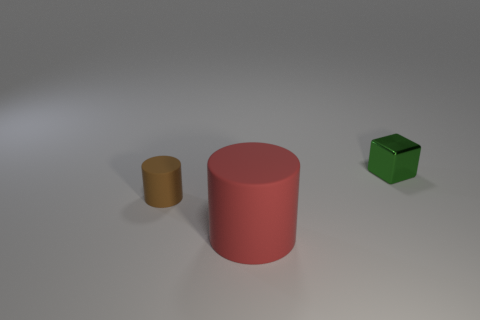How big is the thing on the right side of the big matte thing?
Provide a short and direct response. Small. Does the brown cylinder have the same material as the big cylinder?
Your answer should be compact. Yes. There is a red object that is the same material as the brown cylinder; what is its shape?
Your answer should be very brief. Cylinder. Is there anything else that has the same color as the metallic block?
Keep it short and to the point. No. What is the color of the small object that is to the left of the tiny block?
Your answer should be very brief. Brown. There is a object on the right side of the big red cylinder; is it the same color as the small matte object?
Your answer should be compact. No. There is another thing that is the same shape as the brown matte object; what material is it?
Your answer should be compact. Rubber. How many cubes are the same size as the red matte thing?
Your answer should be very brief. 0. What is the shape of the brown matte object?
Ensure brevity in your answer.  Cylinder. What size is the thing that is both behind the red rubber cylinder and on the left side of the green metal object?
Give a very brief answer. Small. 